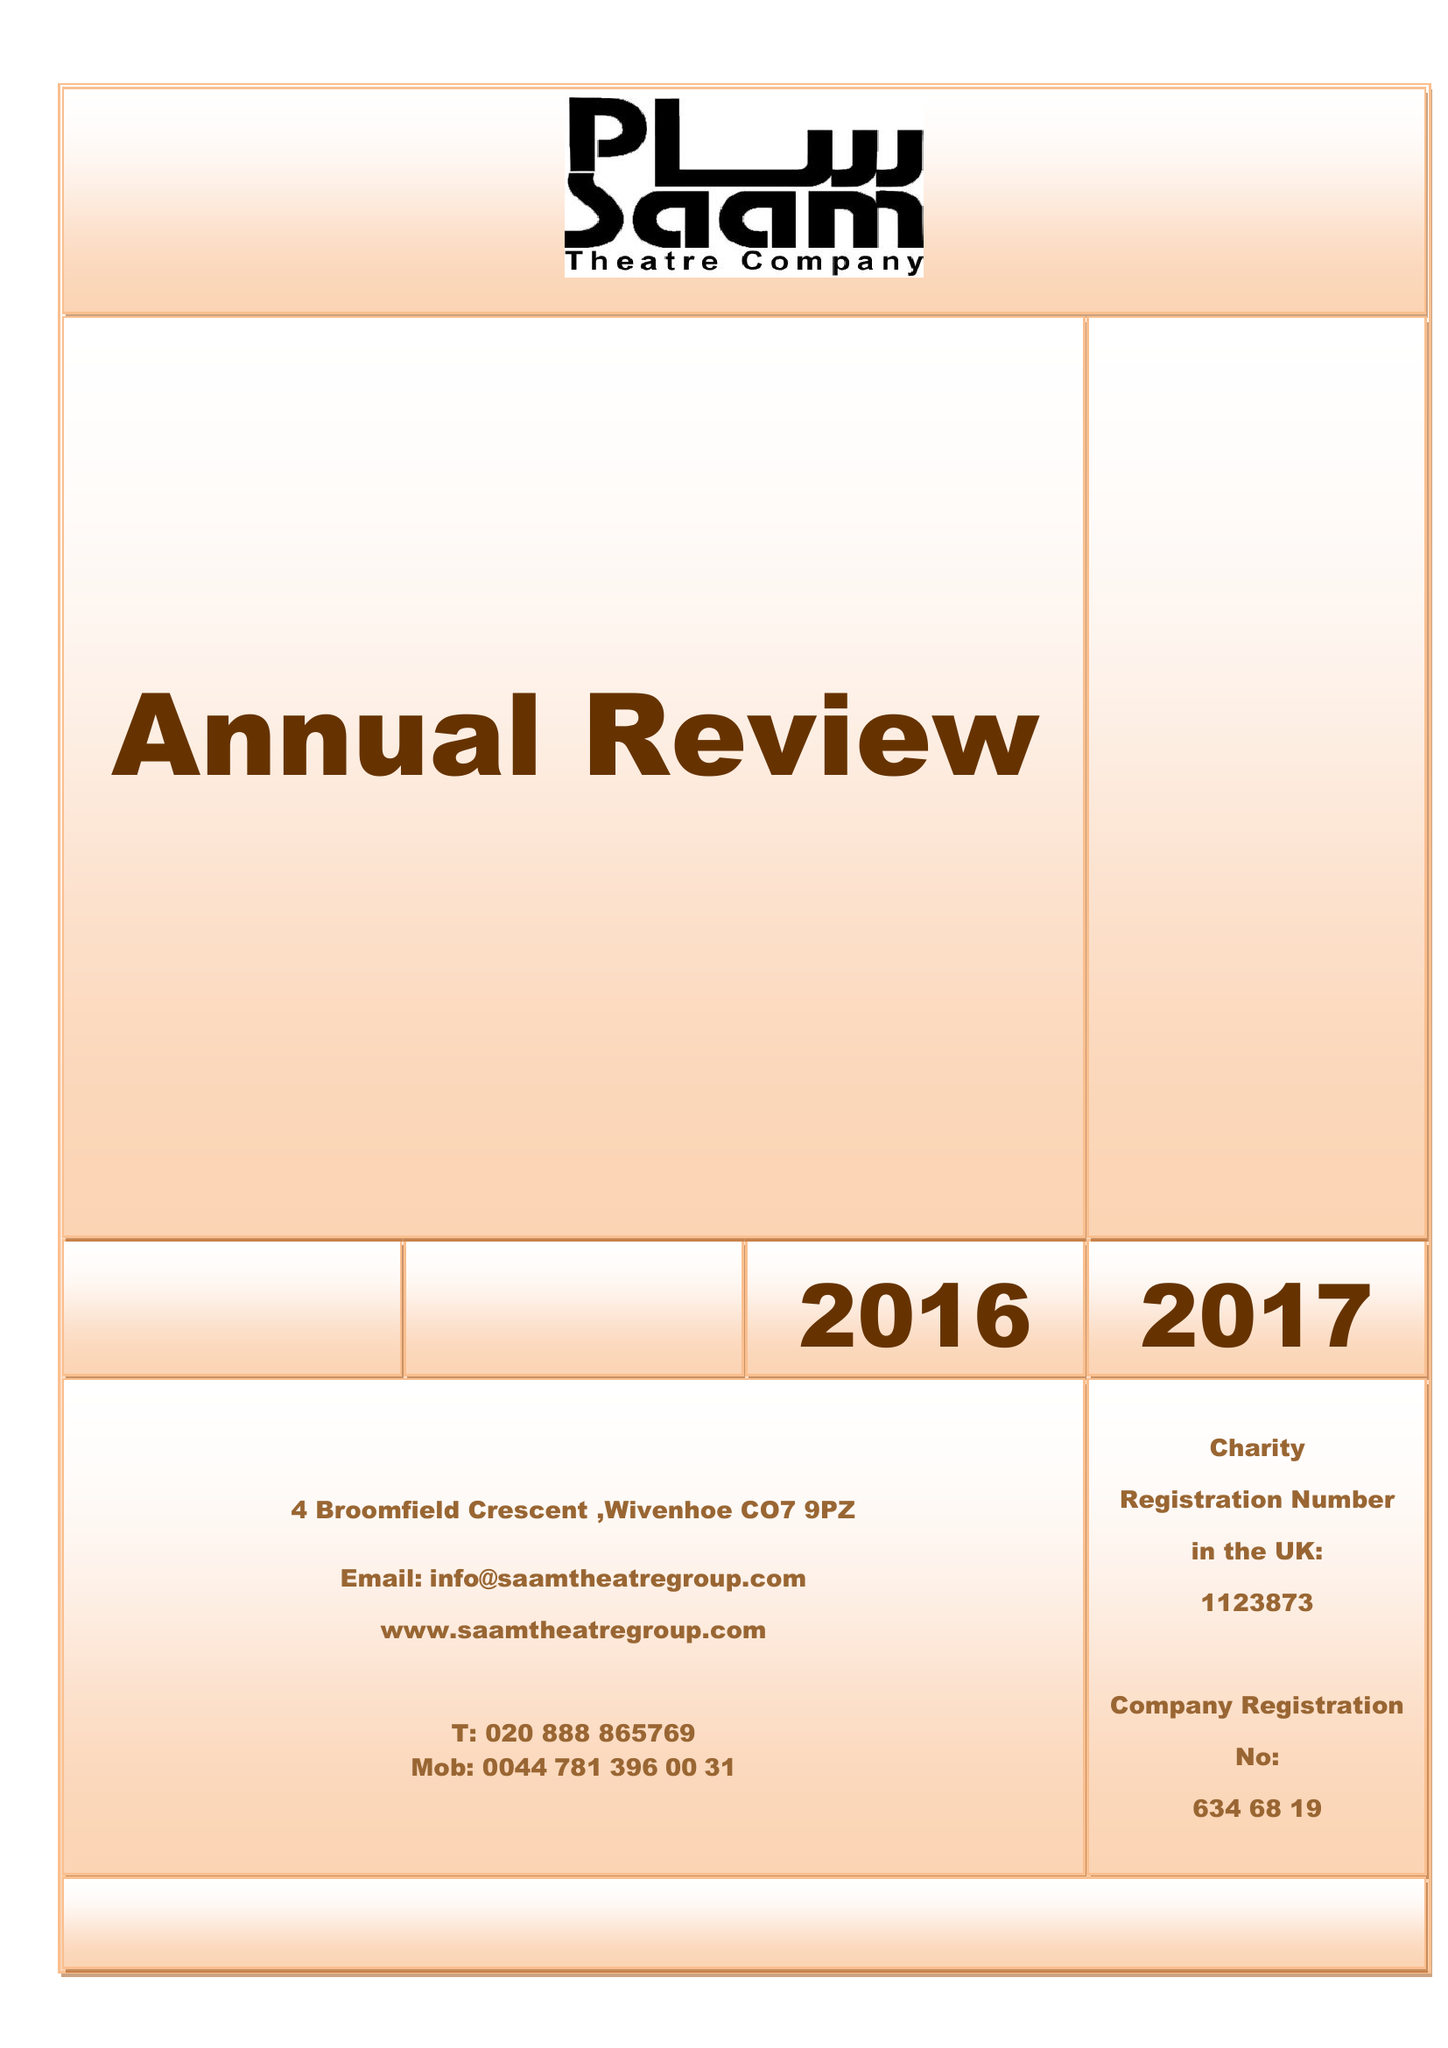What is the value for the address__post_town?
Answer the question using a single word or phrase. COLCHESTER 